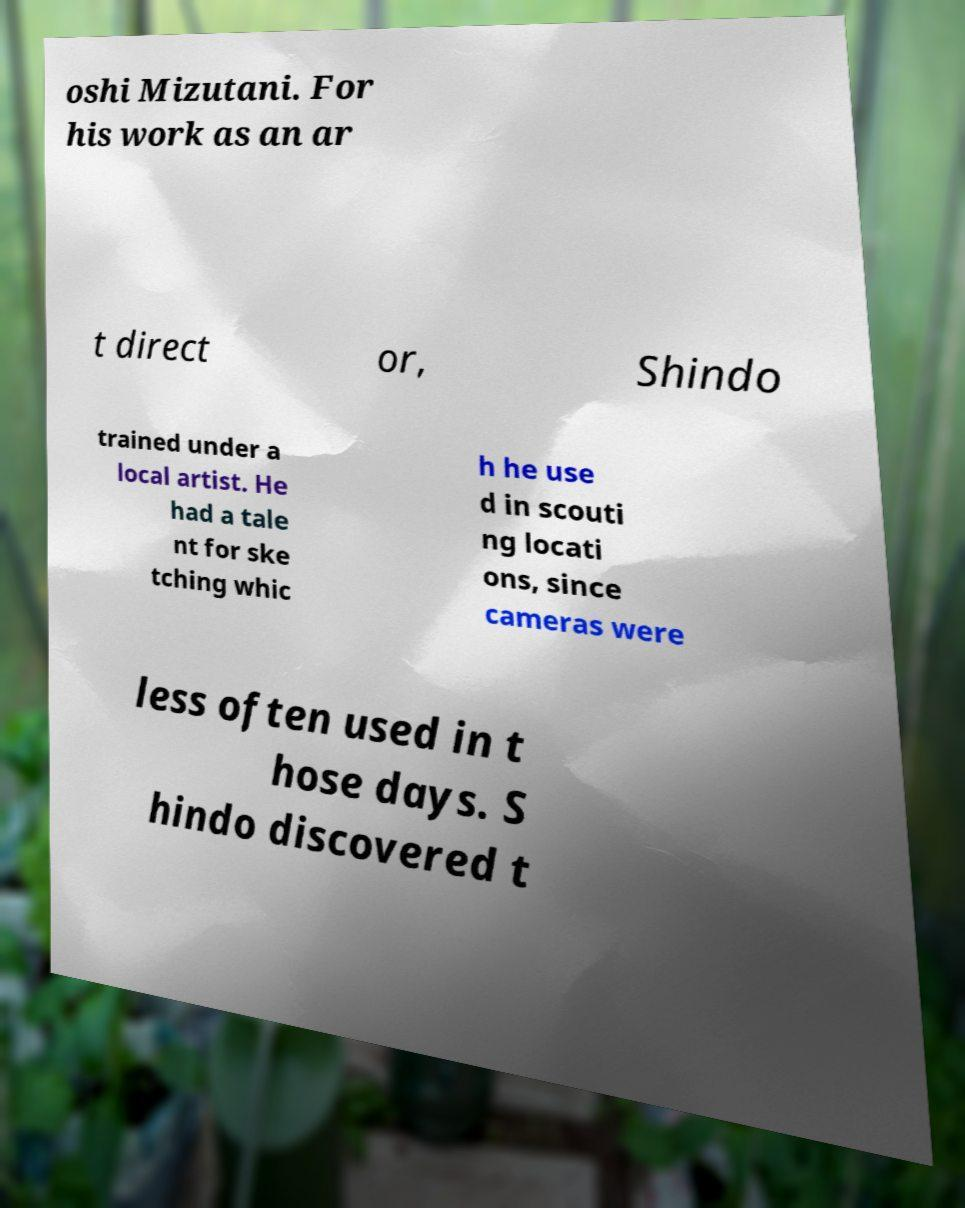Could you extract and type out the text from this image? oshi Mizutani. For his work as an ar t direct or, Shindo trained under a local artist. He had a tale nt for ske tching whic h he use d in scouti ng locati ons, since cameras were less often used in t hose days. S hindo discovered t 